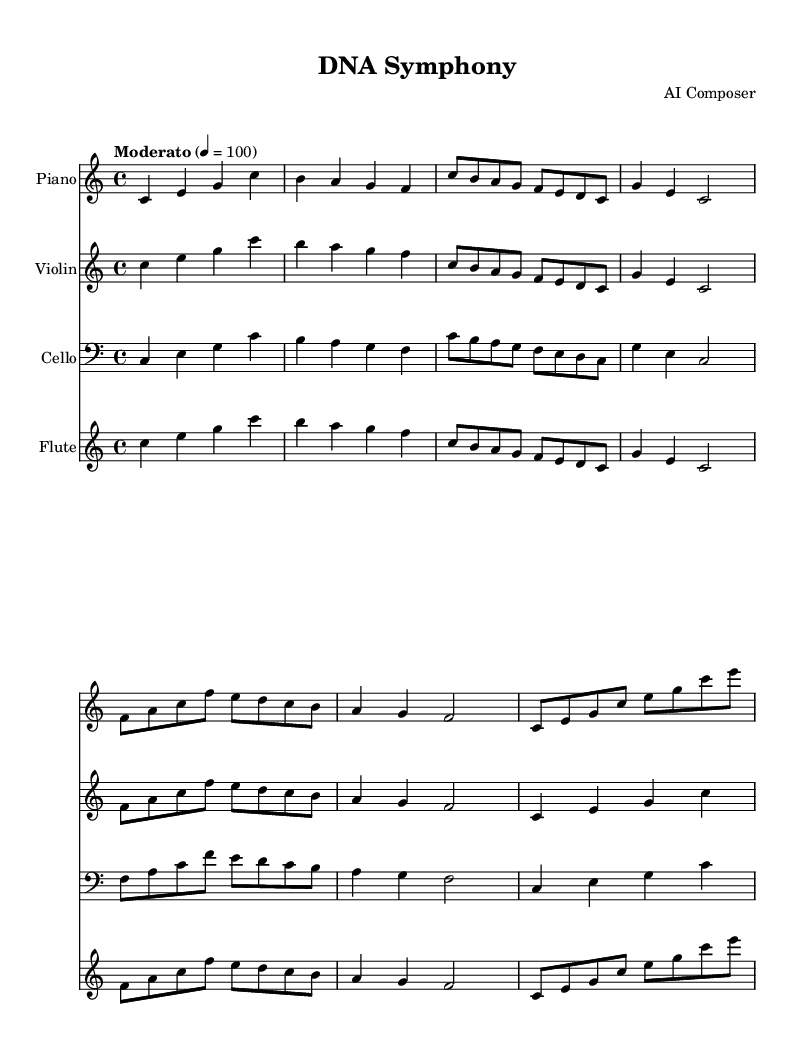What is the key signature of this music? The key signature at the beginning of the staff shows no sharps or flats, indicating that the piece is in C major.
Answer: C major What is the time signature of this music? The time signature is displayed as 4/4, meaning there are four beats in each measure and a quarter note receives one beat.
Answer: 4/4 What is the tempo marking for this piece? The tempo marking indicates a "Moderato" pace, which is typically a moderate speed. The number 4 = 100 tells us the metronome marking.
Answer: Moderato, 100 How many instruments are featured in this score? The score includes four distinct instruments: Piano, Violin, Cello, and Flute, each represented on separate staves.
Answer: Four What is the highest pitch in the Piano part? Looking at the piano part, the highest pitch is the note c in the treble clef, which appears at the start and several other points.
Answer: c Which instruments play the same melodic line in the first measure? The first measure of each of the four instrumental parts features the same melodic line, played by Piano, Violin, Cello, and Flute.
Answer: All instruments In which measure does the first change of note value occur in the Flute part? In the Flute part, the first change of note value occurs at measure 3, where eighth notes are introduced, differing from the quarter notes in measures 1 and 2.
Answer: Measure 3 